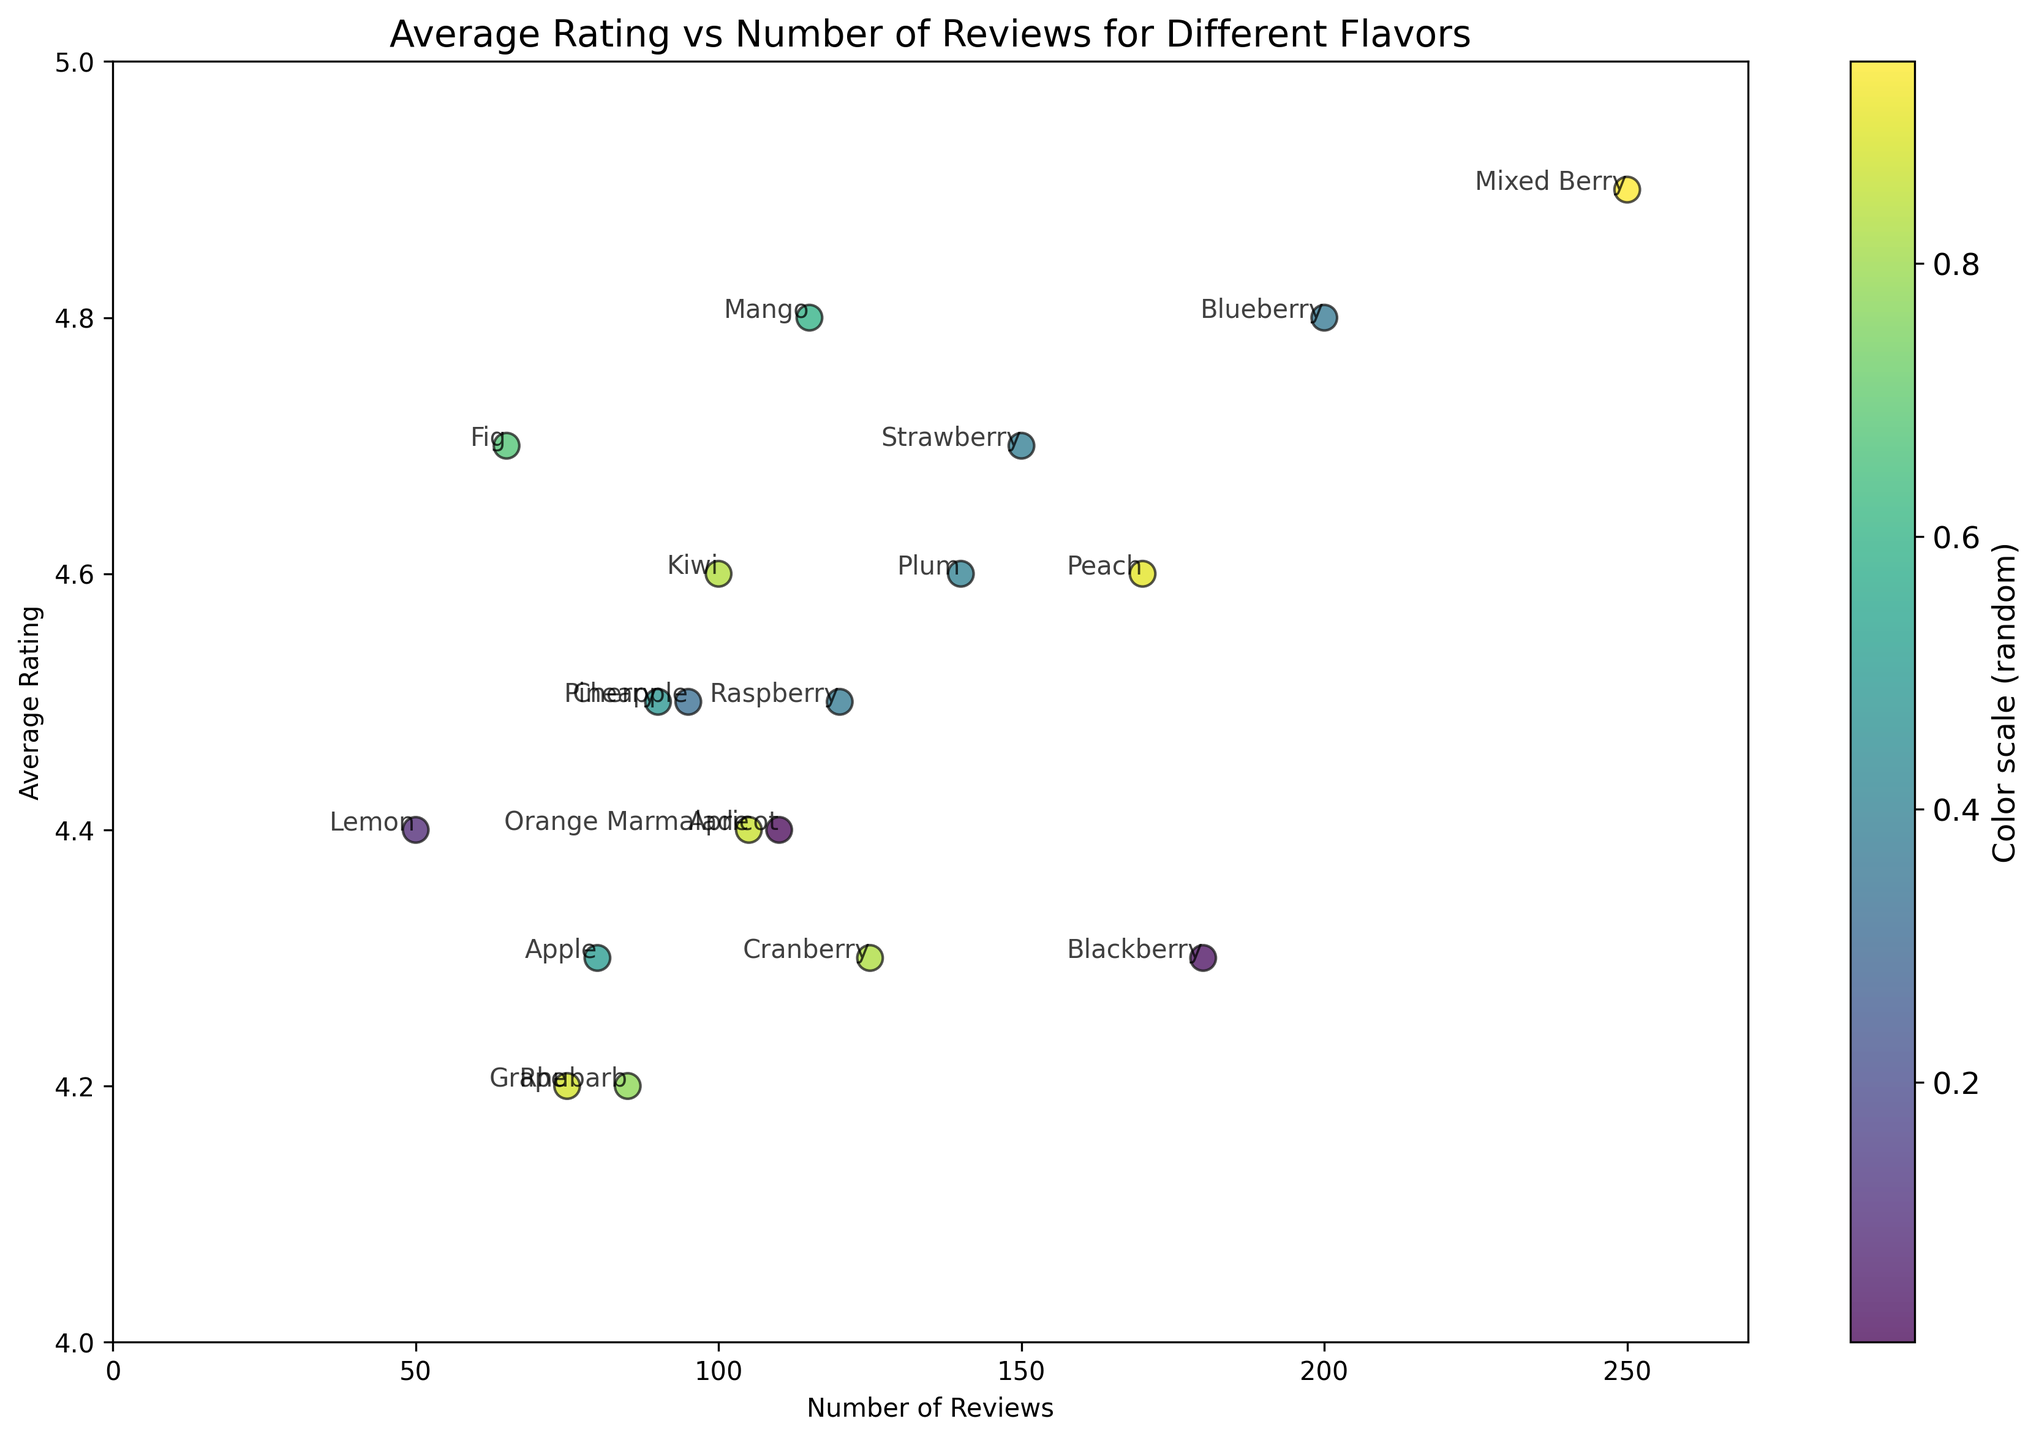What flavor has the highest average rating? The flavor with the highest average rating can be identified by locating the data point with the greatest y-value on the scatter plot. According to the plot, Mixed Berry has the highest average rating.
Answer: Mixed Berry Which flavor has the most number of reviews, and what is its average rating? To find this, locate the data point farthest to the right on the x-axis which represents the number of reviews. The data point for Mixed Berry is furthest to the right, showing it has 250 reviews and an average rating of 4.9.
Answer: Mixed Berry, 4.9 Which flavor has the fewest number of reviews? This is found by locating the data point closest to the left on the x-axis. According to the plot, Lemon has the fewest number of reviews.
Answer: Lemon Compare the average ratings of Strawberry and Raspberry preserves. Which one has a higher rating and by how much? By locating the data points for Strawberry and Raspberry on the plot and comparing their y-values, Strawberry has an average rating of 4.7 and Raspberry has 4.5. Therefore, Strawberry's rating is higher by 0.2.
Answer: Strawberry, 0.2 Is there a flavor with fewer than 100 reviews but an average rating above 4.5? If so, which one(s)? Inspect data points for x-values less than 100 and y-values greater than 4.5. According to the plot, Mango and Fig both fit these conditions.
Answer: Mango, Fig Which flavor with more than 150 reviews has the lowest average rating, and what is that rating? Look for data points with x-values greater than 150 and identify the one with the smallest y-value. Blackberry has more than 150 reviews (180) and the lowest average rating (4.3) among those flavors.
Answer: Blackberry, 4.3 What is the total number of reviews for flavors with an average rating greater than or equal to 4.5? Identify data points with y-values of 4.5 or above, then sum their x-values: Strawberry (150), Raspberry (120), Blueberry (200), Peach (170), Mixed Berry (250), Cherry (90), Plum (140), Kiwi (100), Mango (115), Pineapple (95). The total is 1430 reviews.
Answer: 1430 Compare the average rating between flavors with fewer than 100 reviews and those with more than 200 reviews. Which group has a higher average rating? Group flavors based on their number of reviews and then calculate the average rating of each group. Under 100 reviews: Cranberry (125), Rhubarb (85), Apple (80), Grape (75), Orange Marmalade (105), Pineapple (95), Lemon (50), and Mango (115). Above 200 reviews: Blueberry (200), Mixed Berry (250). The average for under 100 reviews ≈ 4.4 and for above 200 reviews ≈ 4.85. Therefore, above 200 reviews group has a higher average rating.
Answer: Above 200 reviews 